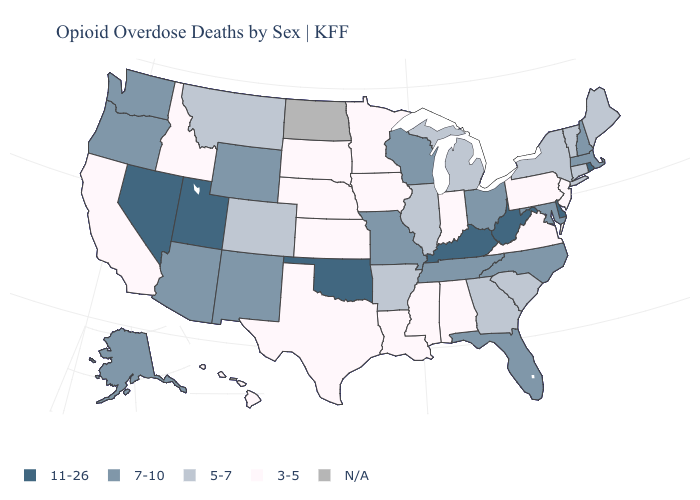What is the value of Ohio?
Short answer required. 7-10. Does the map have missing data?
Quick response, please. Yes. What is the highest value in the South ?
Write a very short answer. 11-26. Is the legend a continuous bar?
Keep it brief. No. What is the value of Nebraska?
Give a very brief answer. 3-5. Name the states that have a value in the range 5-7?
Concise answer only. Arkansas, Colorado, Connecticut, Georgia, Illinois, Maine, Michigan, Montana, New York, South Carolina, Vermont. Among the states that border North Dakota , does Montana have the highest value?
Concise answer only. Yes. Does the map have missing data?
Quick response, please. Yes. What is the value of Pennsylvania?
Quick response, please. 3-5. Which states have the lowest value in the South?
Quick response, please. Alabama, Louisiana, Mississippi, Texas, Virginia. Name the states that have a value in the range 3-5?
Concise answer only. Alabama, California, Hawaii, Idaho, Indiana, Iowa, Kansas, Louisiana, Minnesota, Mississippi, Nebraska, New Jersey, Pennsylvania, South Dakota, Texas, Virginia. Does the map have missing data?
Be succinct. Yes. What is the value of Connecticut?
Short answer required. 5-7. Does Rhode Island have the highest value in the Northeast?
Keep it brief. Yes. Among the states that border Oklahoma , does Texas have the highest value?
Write a very short answer. No. 